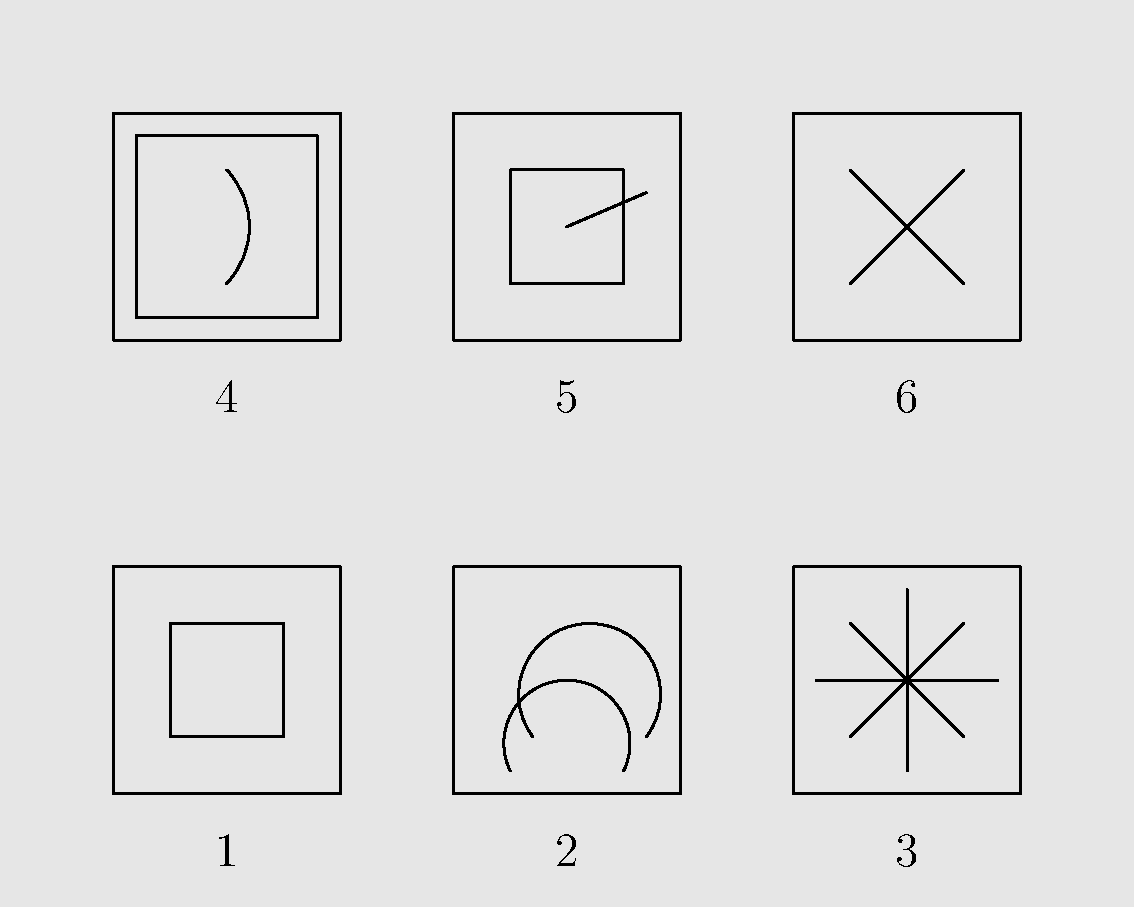Analyze the visual symbolism in "The Lady from Shanghai" using the storyboard sketches provided. Which recurring motif is prominently featured across multiple frames, and how does it contribute to the film's themes of deception and fractured reality? 1. Examine Frame 1: This shows a simple mirror scene, introducing the motif of reflections.

2. Look at Frame 2: The funhouse mirrors represent distorted reality, a key theme in the film.

3. Observe Frame 3: The shattered glass symbolizes broken illusions and fragmented truth.

4. Frame 4 depicts an aquarium scene, which, while not directly related to mirrors, creates a sense of distorted vision through water.

5. In Frame 5, we see a broken mirror alongside a pistol, combining the mirror motif with violence.

6. Frame 6 shows the climactic shootout, likely set in a hall of mirrors as in the film's famous finale.

7. Identify the recurring element: Mirrors and reflections appear in Frames 1, 2, 3, 5, and 6.

8. Analyze the symbolism: Mirrors represent the theme of deception, showing characters' duplicity and the illusory nature of reality in the film.

9. Connect to the film's narrative: The prevalence of mirrors and distorted reflections underscores the complex, deceptive relationships between characters and the blurring of truth and illusion.
Answer: Mirrors and reflections, symbolizing deception and fractured reality. 